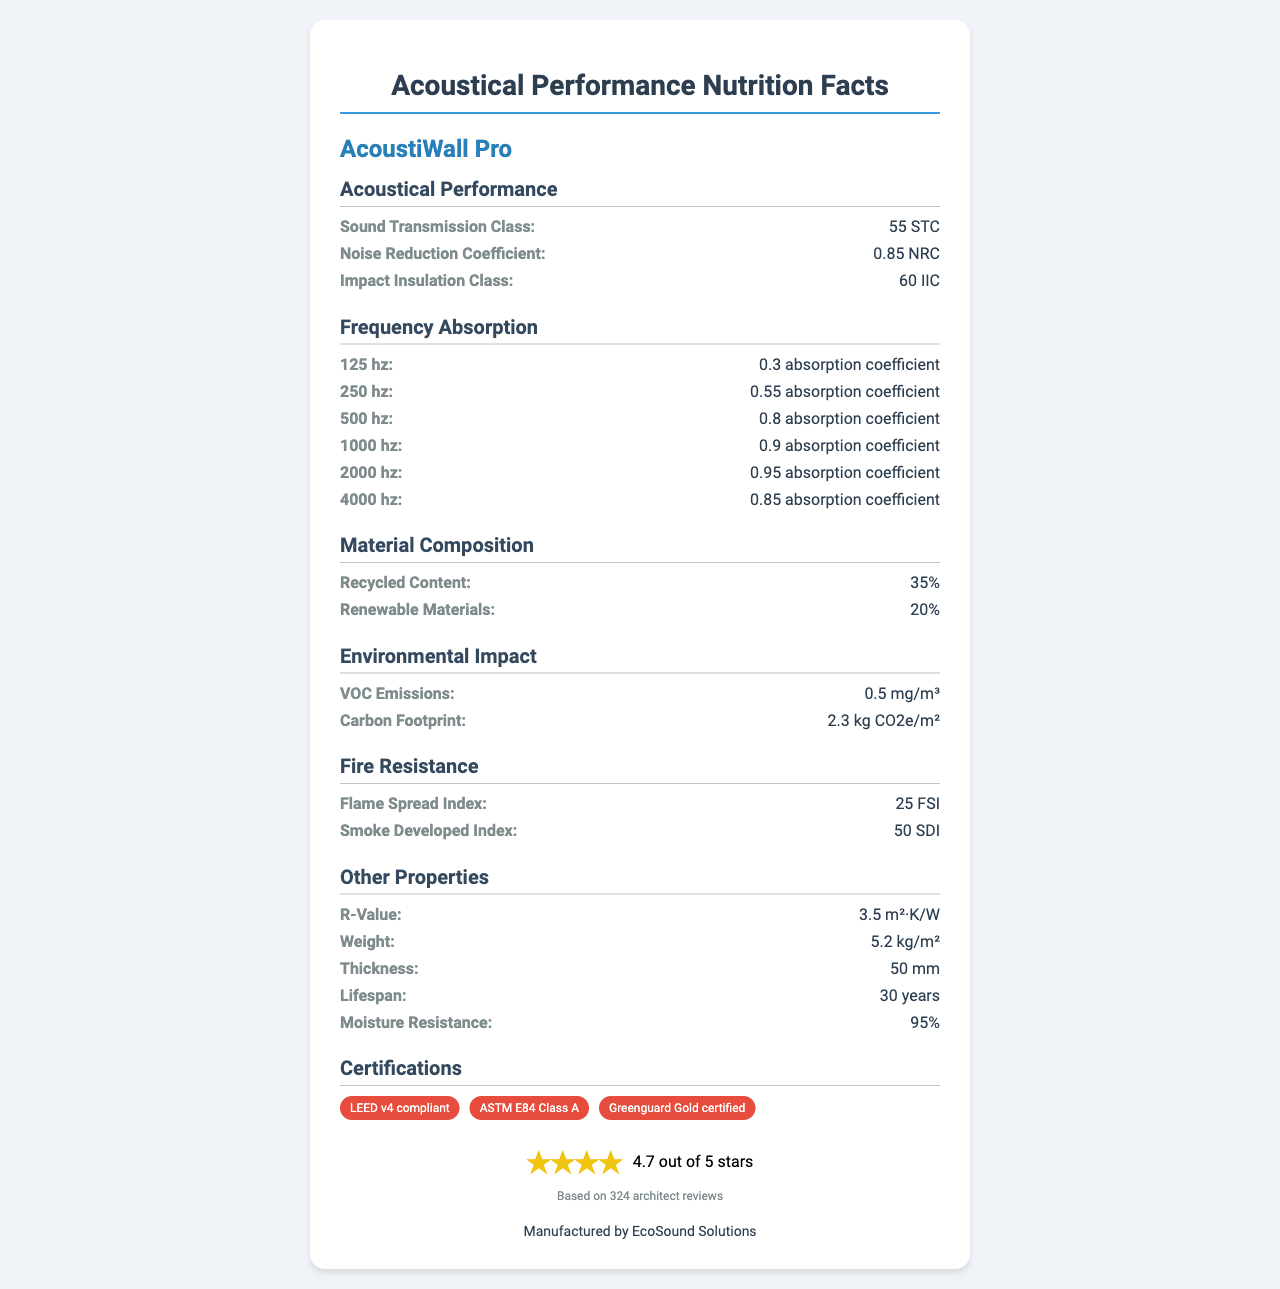what is the Sound Transmission Class (STC) value for AcoustiWall Pro? The document states that the Sound Transmission Class is 55 STC.
Answer: 55 STC what is the Noise Reduction Coefficient (NRC) value of the material? According to the document, the Noise Reduction Coefficient value is 0.85 NRC.
Answer: 0.85 NRC what is the Impact Insulation Class (IIC) value listed in the document? The Impact Insulation Class value is stated as 60 IIC in the document.
Answer: 60 IIC how much recycled content does AcoustiWall Pro contain? The document specifies that AcoustiWall Pro contains 35% recycled content.
Answer: 35% what is the flame spread index of this soundproofing material? The flame spread index is stated as 25 FSI in the document.
Answer: 25 FSI what is the absorption coefficient at 1000 Hz? The absorption coefficient at 1000 Hz is listed as 0.90 in the document.
Answer: 0.90 which material has a higher R-value, AcoustiWall Pro or another insulation material with an R-value of 4.0? A. AcoustiWall Pro B. Other insulation material C. Both have the same R-value AcoustiWall Pro has an R-value of 3.5, which is lower than 4.0.
Answer: B how many certifications does AcoustiWall Pro have? A. Two B. Three C. Four D. One The document lists three certifications: LEED v4 compliant, ASTM E84 Class A, and Greenguard Gold certified.
Answer: B does AcoustiWall Pro have any VOC emissions? The document mentions VOC emissions of 0.5 mg/m³.
Answer: Yes what are the primary aspects assessed in the acoustical performance section? This section elaborates on the material's performance in terms of sound transmission, noise reduction, and impact insulation.
Answer: The acoustical performance section includes Sound Transmission Class (STC), Noise Reduction Coefficient (NRC), and Impact Insulation Class (IIC). describe the overall content of the document. The document is a comprehensive summary of the technical specifications and performance metrics of the AcoustiWall Pro product, aimed at providing relevant information to architecture enthusiasts and professionals.
Answer: The document provides detailed information on the acoustical performance, frequency absorption, material composition, environmental impact, fire resistance, thermal properties, installation measures, durability, and certifications of the AcoustiWall Pro soundproofing material. Additionally, it highlights the manufacturer and project feedback ratings. what is the smoke developed index (SDI) for AcoustiWall Pro? The document states that the smoke developed index is 50 SDI.
Answer: 50 SDI how many architect reviews contribute to the project feedback rating? According to the document, the project feedback rating is based on 324 architect reviews.
Answer: 324 architect reviews which manufacturer produces AcoustiWall Pro? The document mentions that AcoustiWall Pro is manufactured by EcoSound Solutions.
Answer: EcoSound Solutions what is the absorption coefficient at 125 Hz? The document lists an absorption coefficient of 0.30 at 125 Hz.
Answer: 0.30 how is the feedback rating of AcoustiWall Pro presented in the document? This information is clearly outlined beneath the certifications section in the document.
Answer: The feedback rating is given as 4.7 out of 5 stars based on 324 architect reviews. what percentage of renewable materials is used in AcoustiWall Pro's composition? The document states that AcoustiWall Pro uses 20% renewable materials.
Answer: 20% what is the weight of AcoustiWall Pro per square meter? A. 4.2 kg/m² B. 5.2 kg/m² C. 6.2 kg/m² The document lists the weight as 5.2 kg/m².
Answer: B what type of certification is not present for AcoustiWall Pro from the following options? A. LEED v4 compliant B. ISO 9001 C. ASTM E84 Class A D. Greenguard Gold certified The document does not mention ISO 9001 certification.
Answer: B 